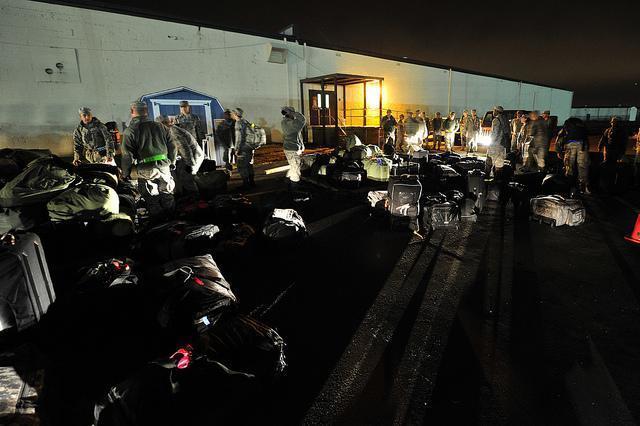How many suitcases are visible?
Give a very brief answer. 2. How many people are in the picture?
Give a very brief answer. 2. 